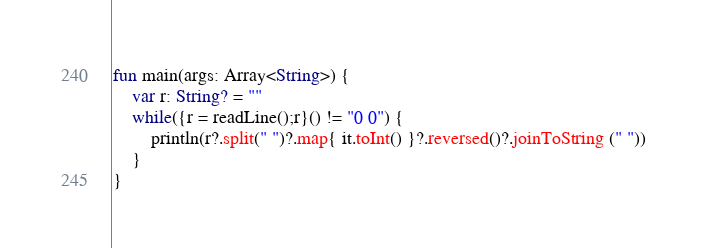<code> <loc_0><loc_0><loc_500><loc_500><_Kotlin_>fun main(args: Array<String>) {
    var r: String? = ""
    while({r = readLine();r}() != "0 0") {
        println(r?.split(" ")?.map{ it.toInt() }?.reversed()?.joinToString (" "))
    }
}
</code> 